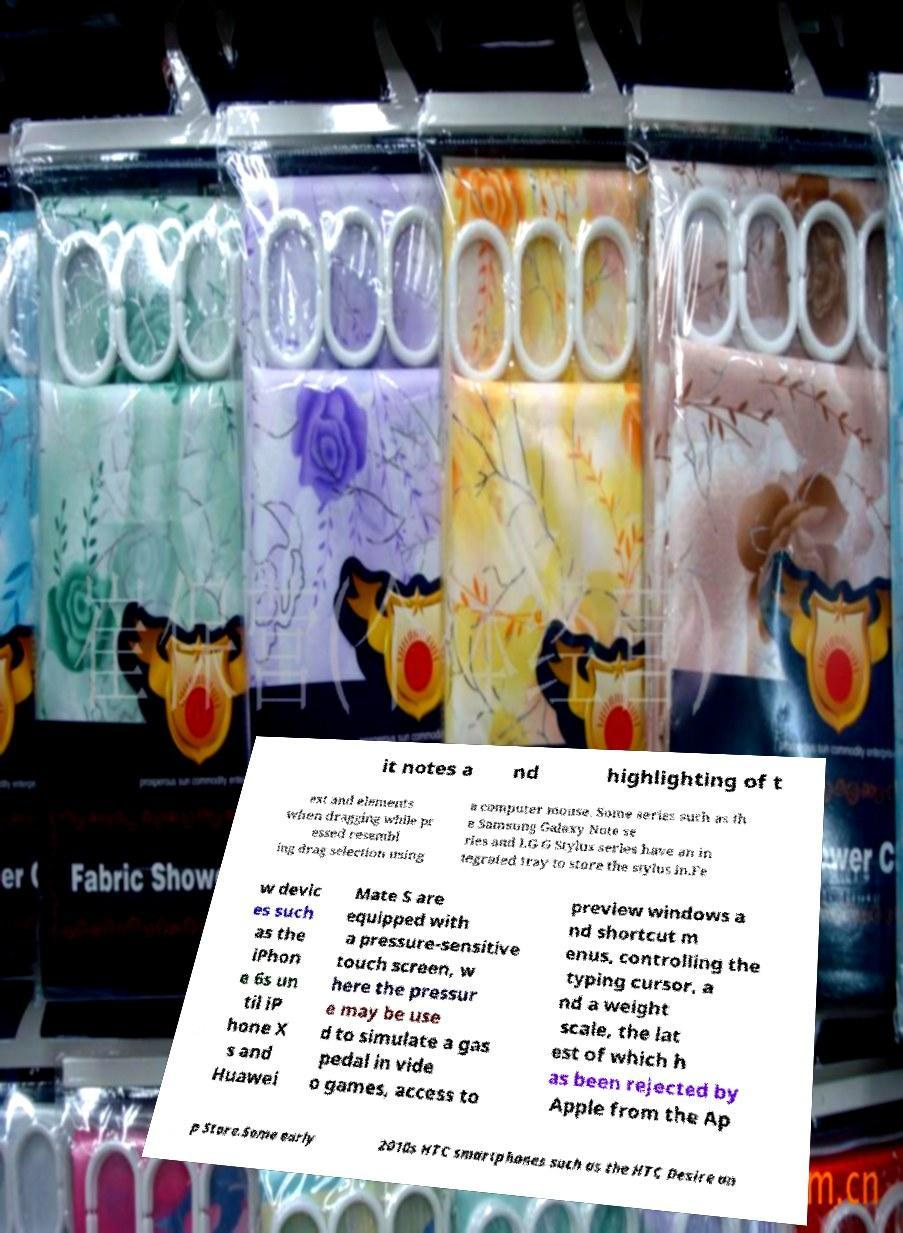Please read and relay the text visible in this image. What does it say? it notes a nd highlighting of t ext and elements when dragging while pr essed resembl ing drag selection using a computer mouse. Some series such as th e Samsung Galaxy Note se ries and LG G Stylus series have an in tegrated tray to store the stylus in.Fe w devic es such as the iPhon e 6s un til iP hone X s and Huawei Mate S are equipped with a pressure-sensitive touch screen, w here the pressur e may be use d to simulate a gas pedal in vide o games, access to preview windows a nd shortcut m enus, controlling the typing cursor, a nd a weight scale, the lat est of which h as been rejected by Apple from the Ap p Store.Some early 2010s HTC smartphones such as the HTC Desire an 